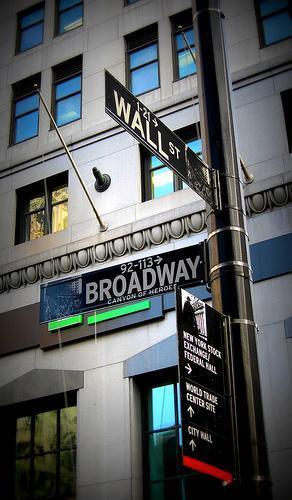How many signs are on the black pole?
Give a very brief answer. 3. 